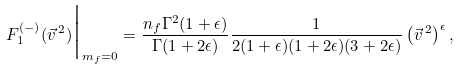<formula> <loc_0><loc_0><loc_500><loc_500>F _ { 1 } ^ { ( - ) } ( \vec { v } ^ { \, 2 } ) \Big | _ { m _ { f } = 0 } = \frac { n _ { f } \Gamma ^ { 2 } ( 1 + \epsilon ) } { \Gamma ( 1 + 2 \epsilon ) } \frac { 1 } { 2 ( 1 + \epsilon ) ( 1 + 2 \epsilon ) ( 3 + 2 \epsilon ) } \left ( \vec { v } ^ { \, 2 } \right ) ^ { \epsilon } ,</formula> 